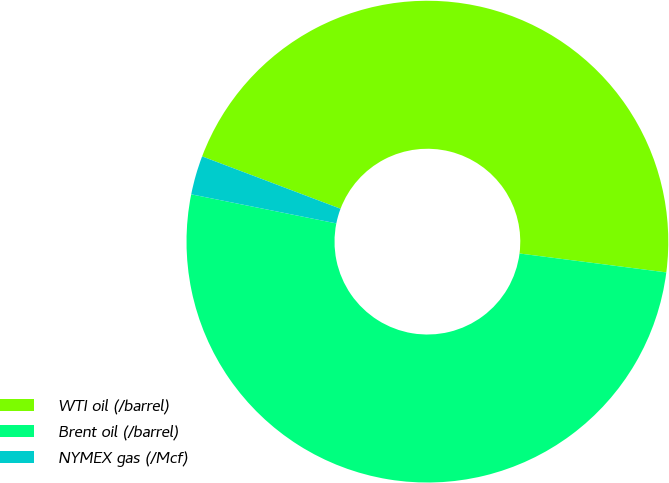<chart> <loc_0><loc_0><loc_500><loc_500><pie_chart><fcel>WTI oil (/barrel)<fcel>Brent oil (/barrel)<fcel>NYMEX gas (/Mcf)<nl><fcel>46.28%<fcel>51.11%<fcel>2.61%<nl></chart> 